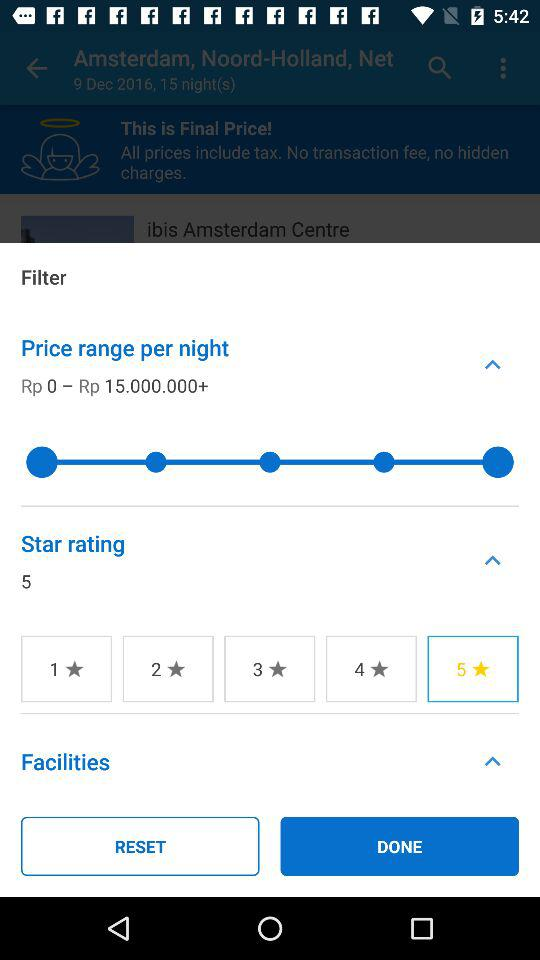Which star rating is selected? The selected star rating is "5 stars". 